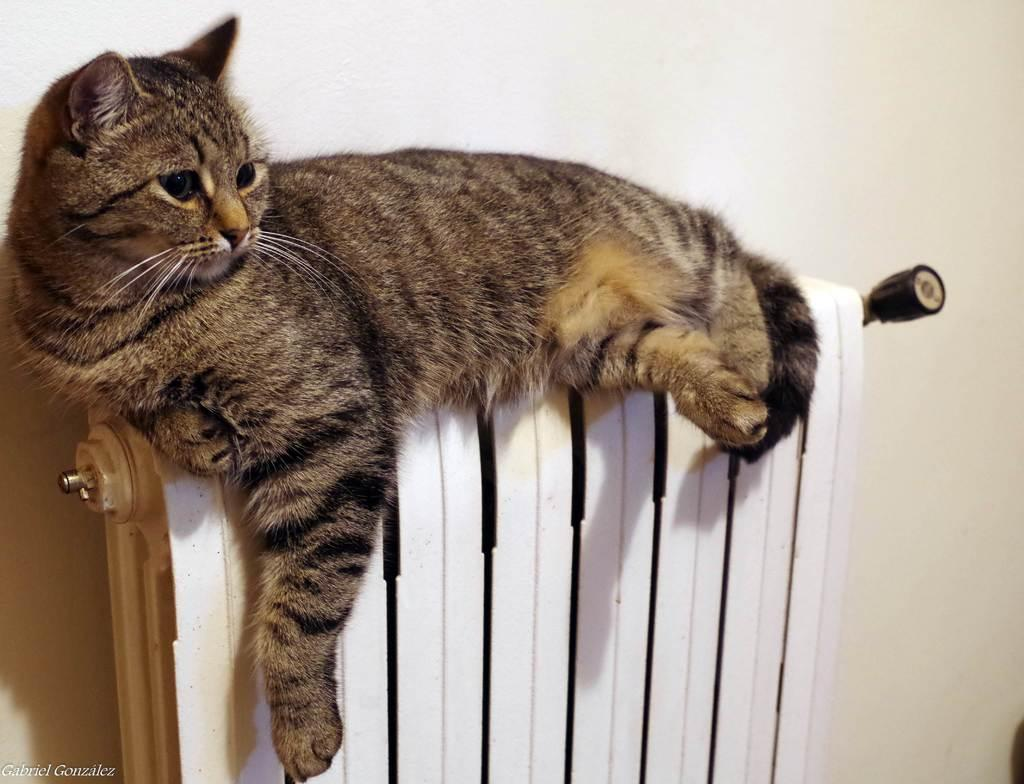What type of animal is in the image? There is a cat in the image. Where is the cat located? The cat is on a radiator. What feature does the radiator have? The radiator has a handle. What else can be seen in the image besides the cat and radiator? There is text visible in the image. How many times does the cat kick the train in the image? There is no train present in the image, so the cat cannot kick it. What type of sugar is being used to sweeten the cat's food in the image? There is no sugar or food visible in the image, so it cannot be determined what type of sugar might be used. 